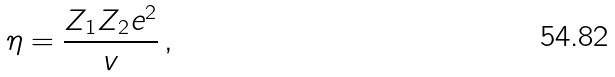Convert formula to latex. <formula><loc_0><loc_0><loc_500><loc_500>\eta = \frac { Z _ { 1 } Z _ { 2 } e ^ { 2 } } { v } \, ,</formula> 